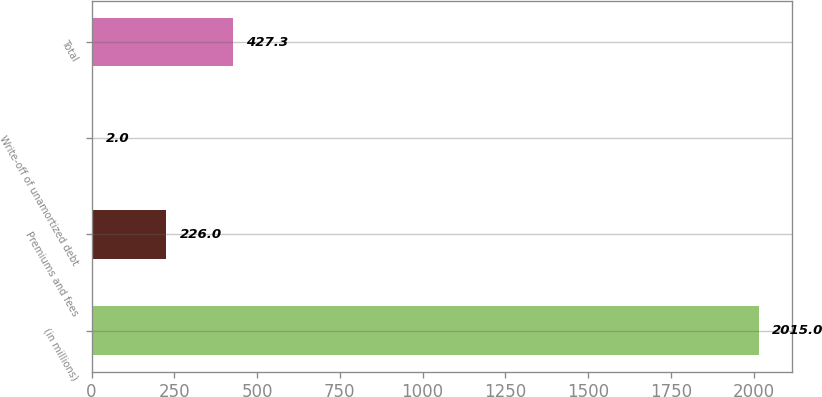Convert chart to OTSL. <chart><loc_0><loc_0><loc_500><loc_500><bar_chart><fcel>(in millions)<fcel>Premiums and fees<fcel>Write-off of unamortized debt<fcel>Total<nl><fcel>2015<fcel>226<fcel>2<fcel>427.3<nl></chart> 